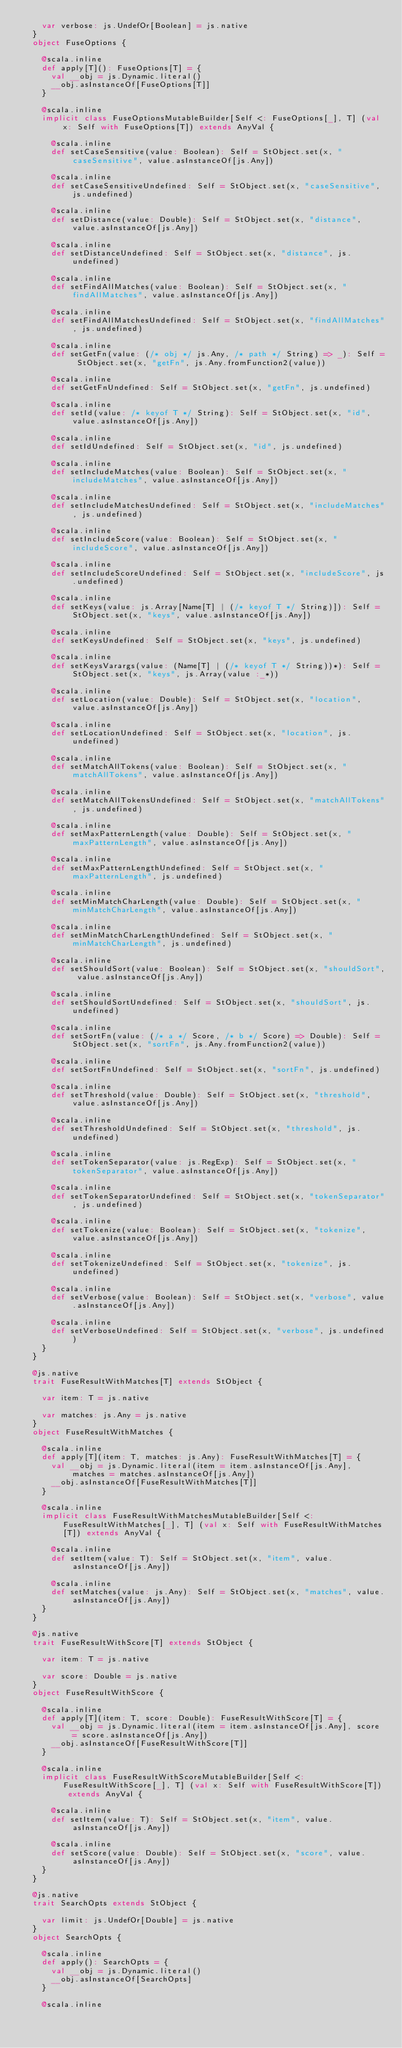Convert code to text. <code><loc_0><loc_0><loc_500><loc_500><_Scala_>    var verbose: js.UndefOr[Boolean] = js.native
  }
  object FuseOptions {
    
    @scala.inline
    def apply[T](): FuseOptions[T] = {
      val __obj = js.Dynamic.literal()
      __obj.asInstanceOf[FuseOptions[T]]
    }
    
    @scala.inline
    implicit class FuseOptionsMutableBuilder[Self <: FuseOptions[_], T] (val x: Self with FuseOptions[T]) extends AnyVal {
      
      @scala.inline
      def setCaseSensitive(value: Boolean): Self = StObject.set(x, "caseSensitive", value.asInstanceOf[js.Any])
      
      @scala.inline
      def setCaseSensitiveUndefined: Self = StObject.set(x, "caseSensitive", js.undefined)
      
      @scala.inline
      def setDistance(value: Double): Self = StObject.set(x, "distance", value.asInstanceOf[js.Any])
      
      @scala.inline
      def setDistanceUndefined: Self = StObject.set(x, "distance", js.undefined)
      
      @scala.inline
      def setFindAllMatches(value: Boolean): Self = StObject.set(x, "findAllMatches", value.asInstanceOf[js.Any])
      
      @scala.inline
      def setFindAllMatchesUndefined: Self = StObject.set(x, "findAllMatches", js.undefined)
      
      @scala.inline
      def setGetFn(value: (/* obj */ js.Any, /* path */ String) => _): Self = StObject.set(x, "getFn", js.Any.fromFunction2(value))
      
      @scala.inline
      def setGetFnUndefined: Self = StObject.set(x, "getFn", js.undefined)
      
      @scala.inline
      def setId(value: /* keyof T */ String): Self = StObject.set(x, "id", value.asInstanceOf[js.Any])
      
      @scala.inline
      def setIdUndefined: Self = StObject.set(x, "id", js.undefined)
      
      @scala.inline
      def setIncludeMatches(value: Boolean): Self = StObject.set(x, "includeMatches", value.asInstanceOf[js.Any])
      
      @scala.inline
      def setIncludeMatchesUndefined: Self = StObject.set(x, "includeMatches", js.undefined)
      
      @scala.inline
      def setIncludeScore(value: Boolean): Self = StObject.set(x, "includeScore", value.asInstanceOf[js.Any])
      
      @scala.inline
      def setIncludeScoreUndefined: Self = StObject.set(x, "includeScore", js.undefined)
      
      @scala.inline
      def setKeys(value: js.Array[Name[T] | (/* keyof T */ String)]): Self = StObject.set(x, "keys", value.asInstanceOf[js.Any])
      
      @scala.inline
      def setKeysUndefined: Self = StObject.set(x, "keys", js.undefined)
      
      @scala.inline
      def setKeysVarargs(value: (Name[T] | (/* keyof T */ String))*): Self = StObject.set(x, "keys", js.Array(value :_*))
      
      @scala.inline
      def setLocation(value: Double): Self = StObject.set(x, "location", value.asInstanceOf[js.Any])
      
      @scala.inline
      def setLocationUndefined: Self = StObject.set(x, "location", js.undefined)
      
      @scala.inline
      def setMatchAllTokens(value: Boolean): Self = StObject.set(x, "matchAllTokens", value.asInstanceOf[js.Any])
      
      @scala.inline
      def setMatchAllTokensUndefined: Self = StObject.set(x, "matchAllTokens", js.undefined)
      
      @scala.inline
      def setMaxPatternLength(value: Double): Self = StObject.set(x, "maxPatternLength", value.asInstanceOf[js.Any])
      
      @scala.inline
      def setMaxPatternLengthUndefined: Self = StObject.set(x, "maxPatternLength", js.undefined)
      
      @scala.inline
      def setMinMatchCharLength(value: Double): Self = StObject.set(x, "minMatchCharLength", value.asInstanceOf[js.Any])
      
      @scala.inline
      def setMinMatchCharLengthUndefined: Self = StObject.set(x, "minMatchCharLength", js.undefined)
      
      @scala.inline
      def setShouldSort(value: Boolean): Self = StObject.set(x, "shouldSort", value.asInstanceOf[js.Any])
      
      @scala.inline
      def setShouldSortUndefined: Self = StObject.set(x, "shouldSort", js.undefined)
      
      @scala.inline
      def setSortFn(value: (/* a */ Score, /* b */ Score) => Double): Self = StObject.set(x, "sortFn", js.Any.fromFunction2(value))
      
      @scala.inline
      def setSortFnUndefined: Self = StObject.set(x, "sortFn", js.undefined)
      
      @scala.inline
      def setThreshold(value: Double): Self = StObject.set(x, "threshold", value.asInstanceOf[js.Any])
      
      @scala.inline
      def setThresholdUndefined: Self = StObject.set(x, "threshold", js.undefined)
      
      @scala.inline
      def setTokenSeparator(value: js.RegExp): Self = StObject.set(x, "tokenSeparator", value.asInstanceOf[js.Any])
      
      @scala.inline
      def setTokenSeparatorUndefined: Self = StObject.set(x, "tokenSeparator", js.undefined)
      
      @scala.inline
      def setTokenize(value: Boolean): Self = StObject.set(x, "tokenize", value.asInstanceOf[js.Any])
      
      @scala.inline
      def setTokenizeUndefined: Self = StObject.set(x, "tokenize", js.undefined)
      
      @scala.inline
      def setVerbose(value: Boolean): Self = StObject.set(x, "verbose", value.asInstanceOf[js.Any])
      
      @scala.inline
      def setVerboseUndefined: Self = StObject.set(x, "verbose", js.undefined)
    }
  }
  
  @js.native
  trait FuseResultWithMatches[T] extends StObject {
    
    var item: T = js.native
    
    var matches: js.Any = js.native
  }
  object FuseResultWithMatches {
    
    @scala.inline
    def apply[T](item: T, matches: js.Any): FuseResultWithMatches[T] = {
      val __obj = js.Dynamic.literal(item = item.asInstanceOf[js.Any], matches = matches.asInstanceOf[js.Any])
      __obj.asInstanceOf[FuseResultWithMatches[T]]
    }
    
    @scala.inline
    implicit class FuseResultWithMatchesMutableBuilder[Self <: FuseResultWithMatches[_], T] (val x: Self with FuseResultWithMatches[T]) extends AnyVal {
      
      @scala.inline
      def setItem(value: T): Self = StObject.set(x, "item", value.asInstanceOf[js.Any])
      
      @scala.inline
      def setMatches(value: js.Any): Self = StObject.set(x, "matches", value.asInstanceOf[js.Any])
    }
  }
  
  @js.native
  trait FuseResultWithScore[T] extends StObject {
    
    var item: T = js.native
    
    var score: Double = js.native
  }
  object FuseResultWithScore {
    
    @scala.inline
    def apply[T](item: T, score: Double): FuseResultWithScore[T] = {
      val __obj = js.Dynamic.literal(item = item.asInstanceOf[js.Any], score = score.asInstanceOf[js.Any])
      __obj.asInstanceOf[FuseResultWithScore[T]]
    }
    
    @scala.inline
    implicit class FuseResultWithScoreMutableBuilder[Self <: FuseResultWithScore[_], T] (val x: Self with FuseResultWithScore[T]) extends AnyVal {
      
      @scala.inline
      def setItem(value: T): Self = StObject.set(x, "item", value.asInstanceOf[js.Any])
      
      @scala.inline
      def setScore(value: Double): Self = StObject.set(x, "score", value.asInstanceOf[js.Any])
    }
  }
  
  @js.native
  trait SearchOpts extends StObject {
    
    var limit: js.UndefOr[Double] = js.native
  }
  object SearchOpts {
    
    @scala.inline
    def apply(): SearchOpts = {
      val __obj = js.Dynamic.literal()
      __obj.asInstanceOf[SearchOpts]
    }
    
    @scala.inline</code> 